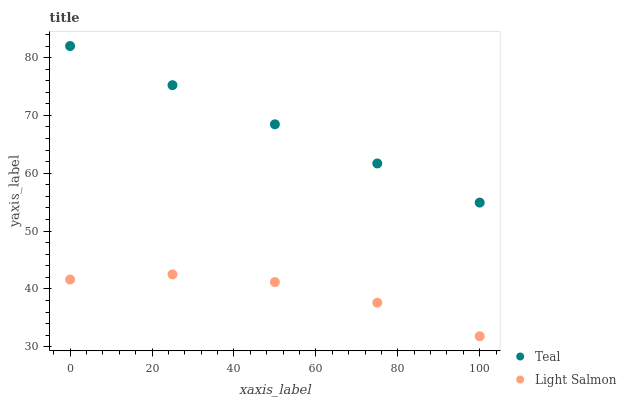Does Light Salmon have the minimum area under the curve?
Answer yes or no. Yes. Does Teal have the maximum area under the curve?
Answer yes or no. Yes. Does Teal have the minimum area under the curve?
Answer yes or no. No. Is Teal the smoothest?
Answer yes or no. Yes. Is Light Salmon the roughest?
Answer yes or no. Yes. Is Teal the roughest?
Answer yes or no. No. Does Light Salmon have the lowest value?
Answer yes or no. Yes. Does Teal have the lowest value?
Answer yes or no. No. Does Teal have the highest value?
Answer yes or no. Yes. Is Light Salmon less than Teal?
Answer yes or no. Yes. Is Teal greater than Light Salmon?
Answer yes or no. Yes. Does Light Salmon intersect Teal?
Answer yes or no. No. 